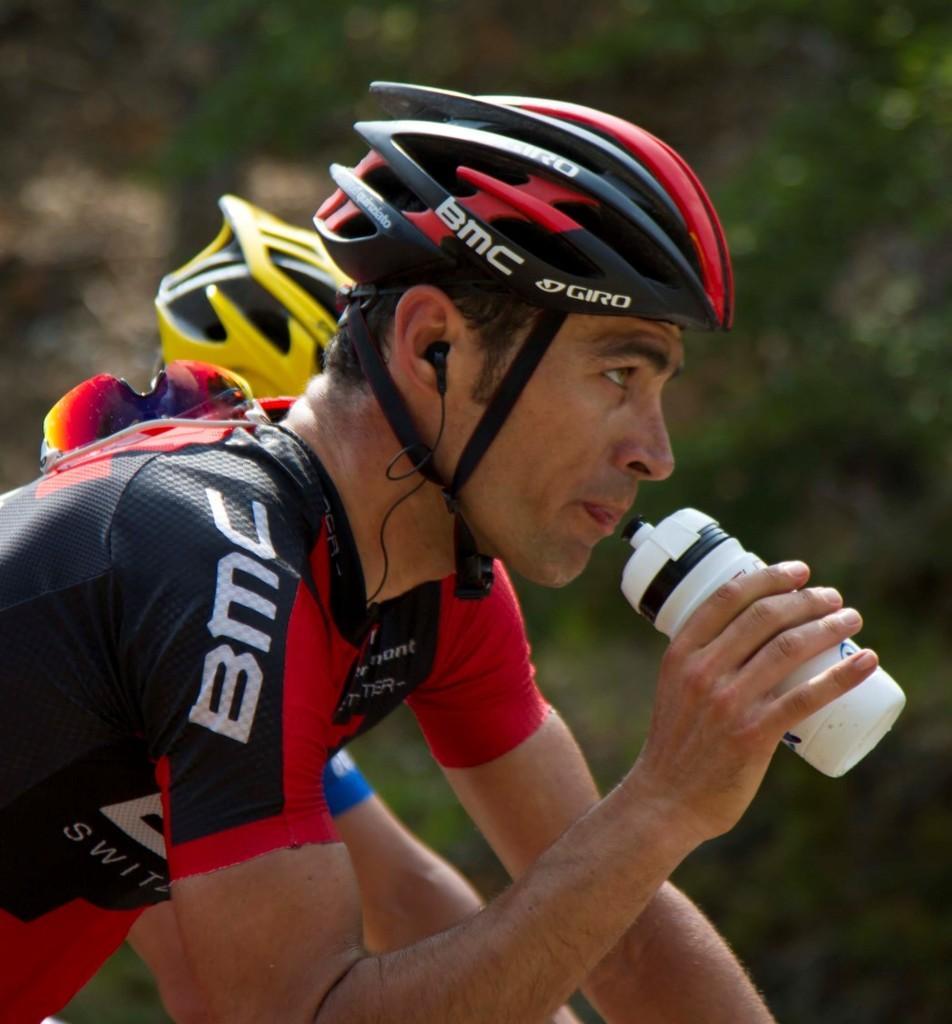Can you describe this image briefly? In this picture we can see two people wore helmets were a man holding a bottle with his hand, goggles, earphones and in the background we can see trees and it is blurry. 